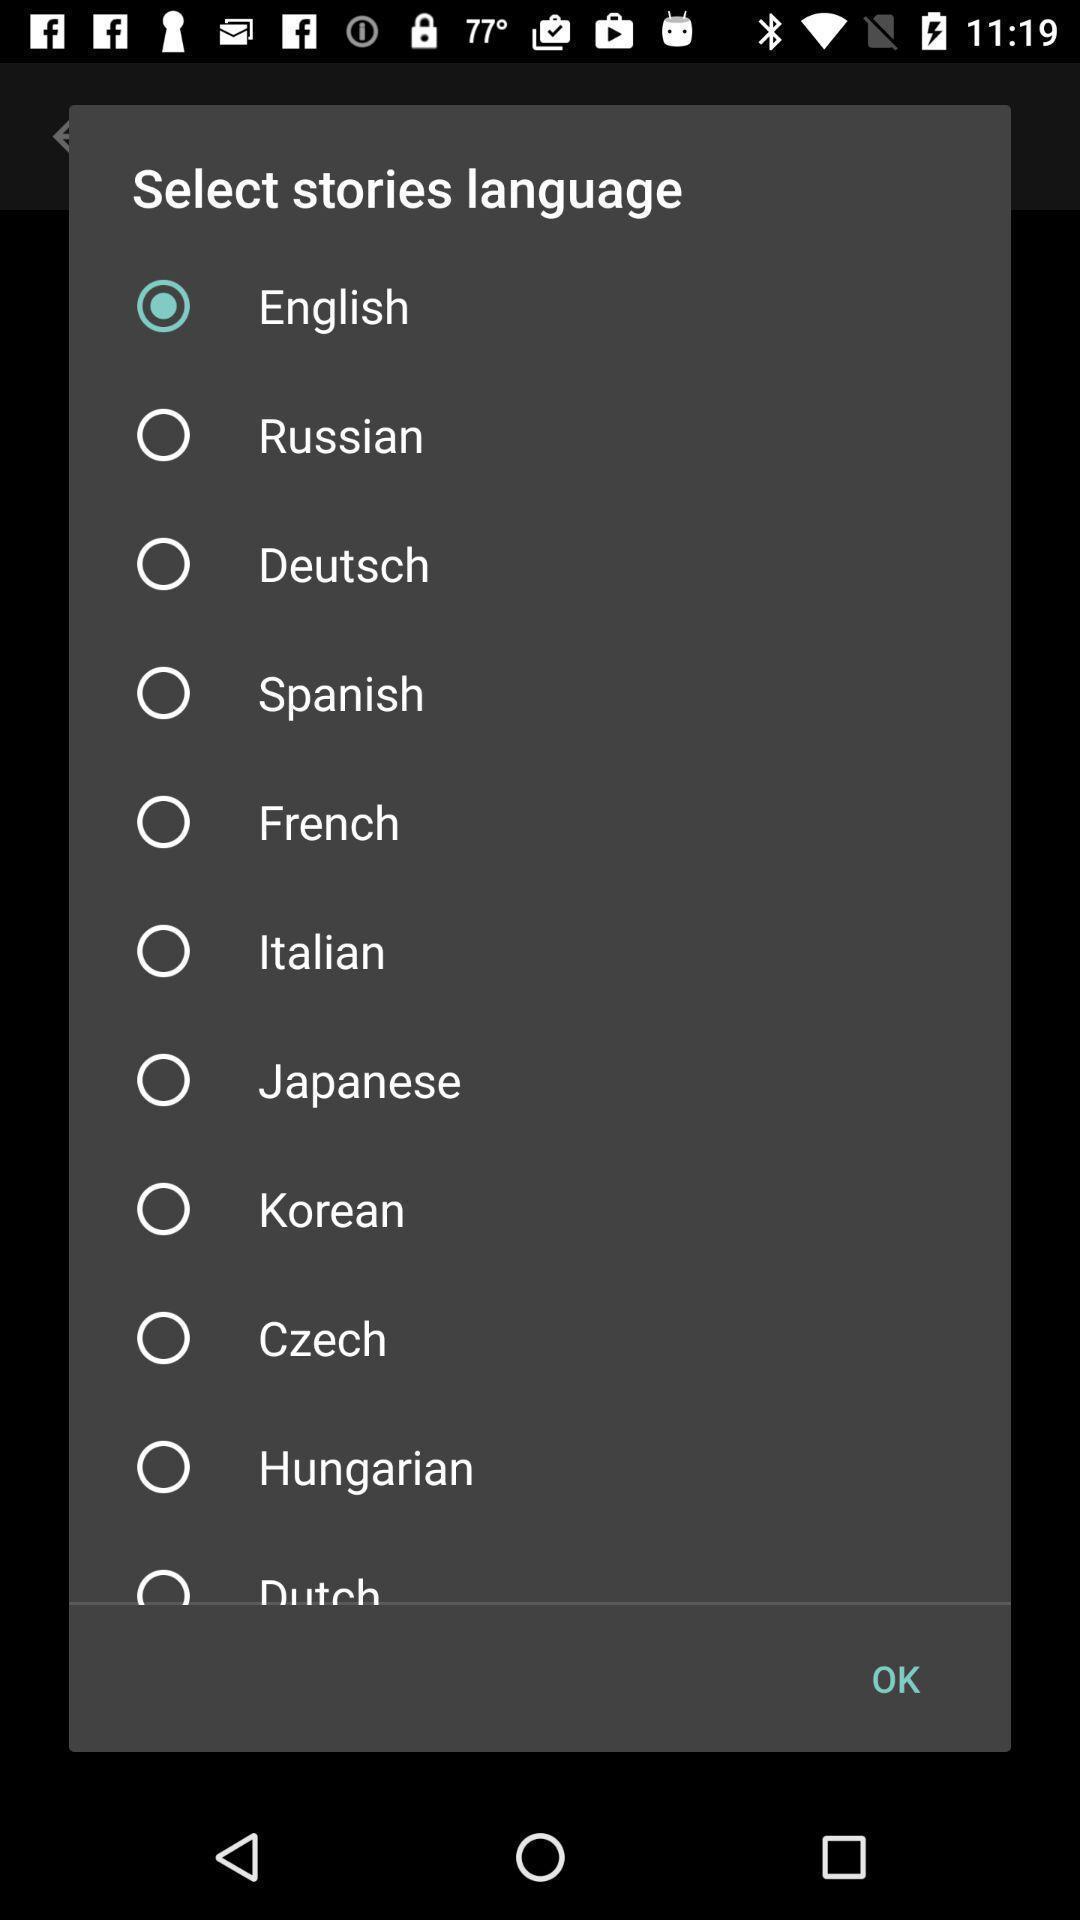Summarize the main components in this picture. Pop-up to select language for stories. 